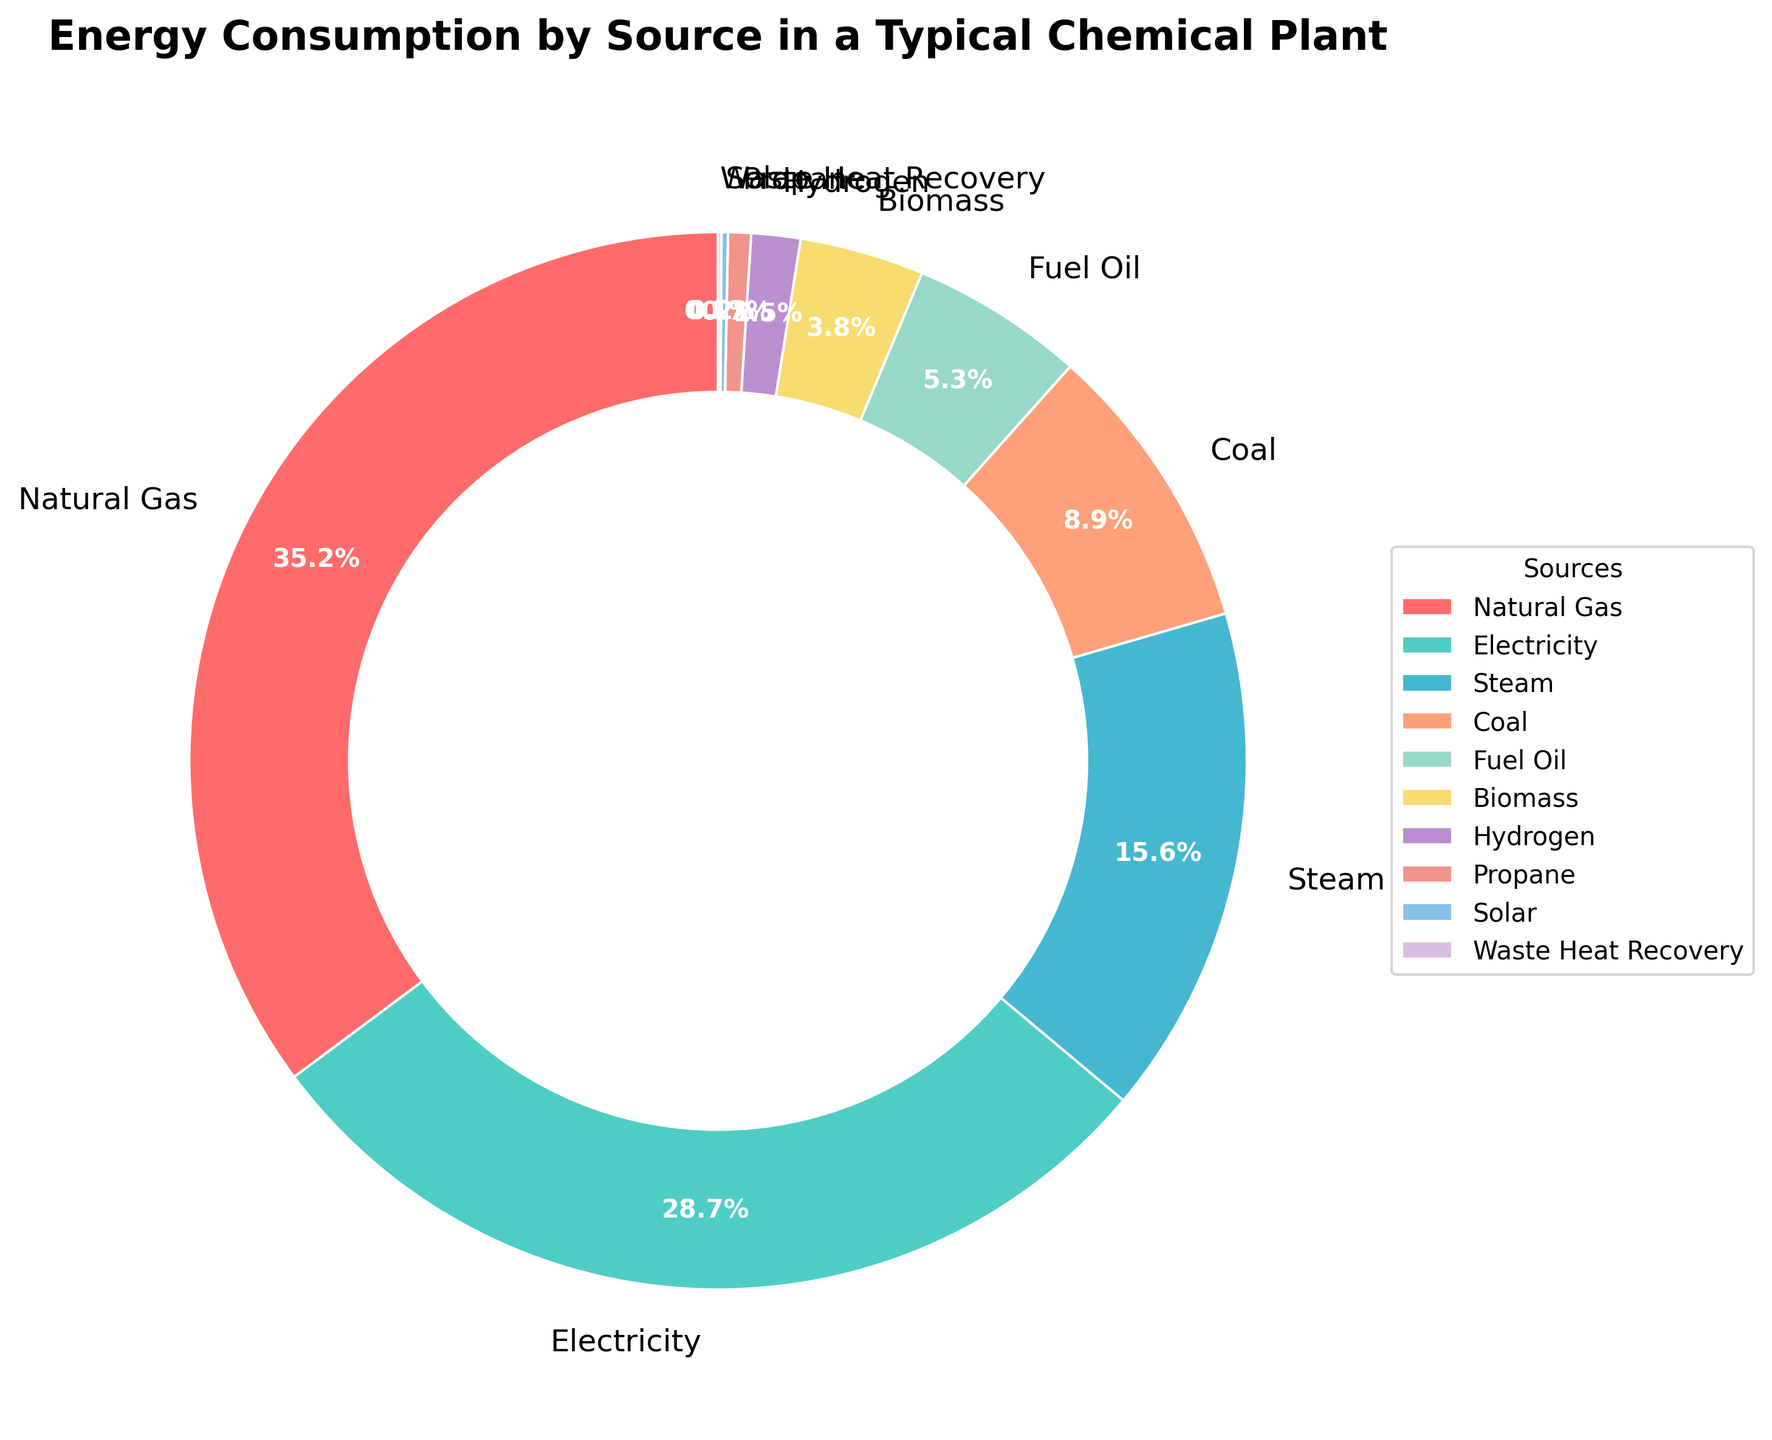What is the percentage of energy consumption for Steam? To find the percentage of energy consumption for Steam, look at the pie chart segment labeled "Steam". It is indicated as 15.6%.
Answer: 15.6% Which energy sources constitute more than 20% of the total energy consumption? Examine the pie segments and their labels. The sources with percentages above 20% are Natural Gas (35.2%) and Electricity (28.7%).
Answer: Natural Gas and Electricity What is the total percentage of energy consumption provided by Coal and Fuel Oil combined? To find the combined percentage, add the values for Coal (8.9%) and Fuel Oil (5.3%). Thus, 8.9% + 5.3% = 14.2%.
Answer: 14.2% Is the energy consumption from Natural Gas greater than the combined consumption of Biomass and Hydrogen? Compare Natural Gas at 35.2% with the sum of Biomass (3.8%) and Hydrogen (1.5%), which equals 3.8% + 1.5% = 5.3%. Since 35.2% > 5.3%, the answer is yes.
Answer: Yes What is the smallest source of energy consumption, and what is its percentage? Identify the smallest pie segment. The label shows "Waste Heat Recovery" at 0.1%, which is indeed the smallest section.
Answer: Waste Heat Recovery, 0.1% What is the combined total of the top three energy sources? Add the percentages of the top three sources: Natural Gas (35.2%), Electricity (28.7%), and Steam (15.6%). So, 35.2% + 28.7% + 15.6% = 79.5%.
Answer: 79.5% Which energy source occupies the second largest segment in the pie chart? Observe the pie chart and identify the second largest segment after Natural Gas. It is Electricity with 28.7%.
Answer: Electricity Is the energy contribution of Solar and Waste Heat Recovery combined larger than Propane? Sum the percentages for Solar (0.2%) and Waste Heat Recovery (0.1%), giving 0.2% + 0.1% = 0.3%. Compare this with Propane at 0.7%, and since 0.3% < 0.7%, the answer is no.
Answer: No How does the percentage of Biomass compare to that of Propane? Compare the values: Biomass is 3.8%, and Propane is 0.7%. Since 3.8% > 0.7%, Biomass has a higher percentage.
Answer: Biomass is higher 